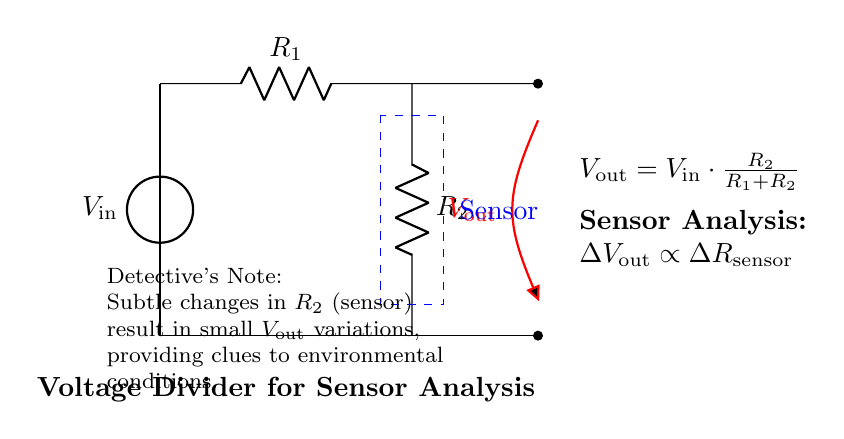What is the input voltage of the circuit? The input voltage is indicated as V_in, which is the source voltage at the top of the circuit.
Answer: V_in What does V_out represent in the circuit? V_out represents the output voltage taken from the voltage divider, influenced by the resistances of R1 and R2.
Answer: Output voltage What is the relationship between V_out and R2 according to the diagram? V_out is proportional to R2, meaning as R2 changes, V_out will change based on the equation shown.
Answer: Proportional How is the output voltage V_out calculated? V_out is calculated using the formula V_out = V_in * (R2 / (R1 + R2)), reflecting the proportion of R2 in the total resistance.
Answer: V_out = V_in * (R2 / (R1 + R2)) What happens to V_out if R2 increases? If R2 increases, V_out will also increase due to the direct proportional relationship, allowing for more voltage to appear across R2.
Answer: Increases What does the detective's note suggest about the circuit's purpose? It suggests that the circuit is used to analyze subtle changes in environmental conditions based on variations in R2, the sensor reading.
Answer: Sensor analysis What component is shown as blue and dashed in the diagram? The blue dashed rectangle represents the sensor, indicating where the sensor will connect to the voltage divider circuit.
Answer: Sensor 